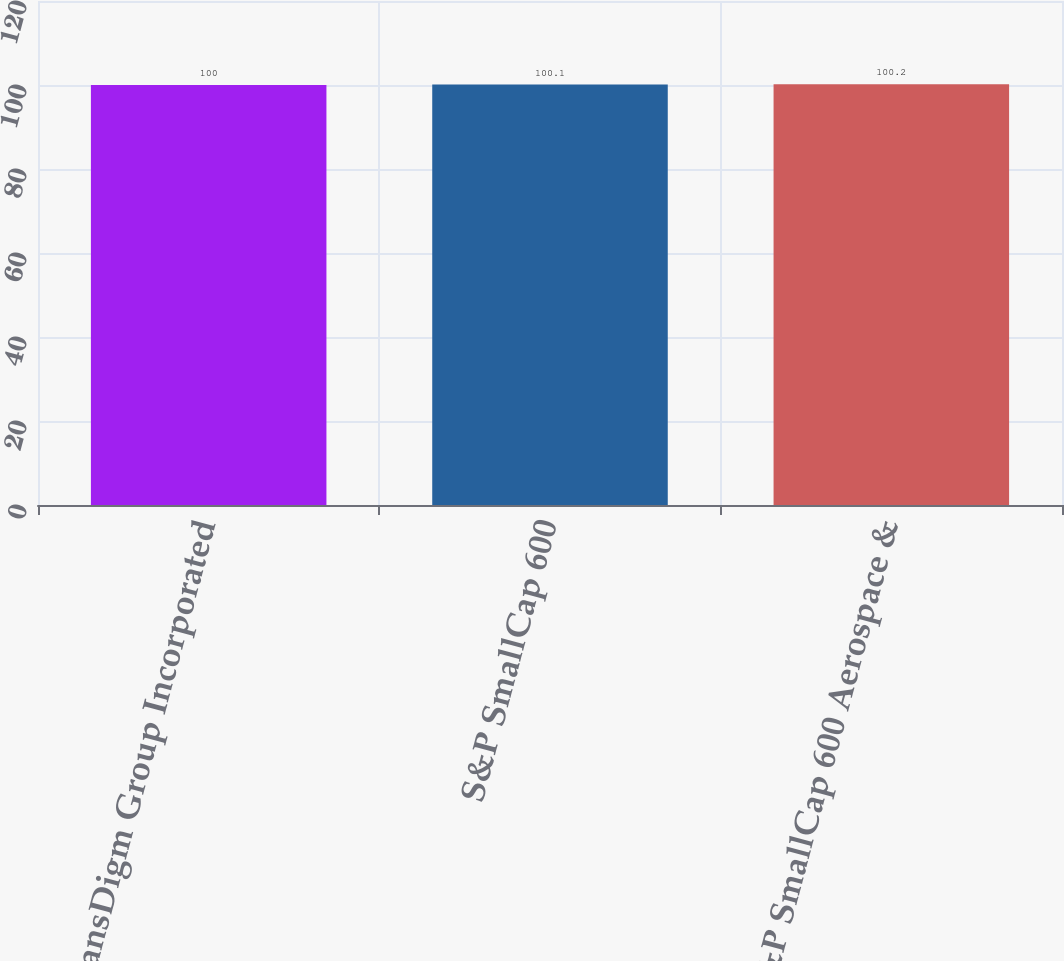<chart> <loc_0><loc_0><loc_500><loc_500><bar_chart><fcel>TransDigm Group Incorporated<fcel>S&P SmallCap 600<fcel>S&P SmallCap 600 Aerospace &<nl><fcel>100<fcel>100.1<fcel>100.2<nl></chart> 